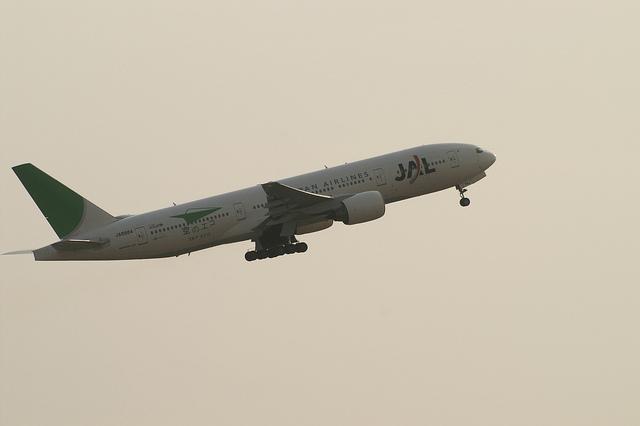How many towers have clocks on them?
Give a very brief answer. 0. 